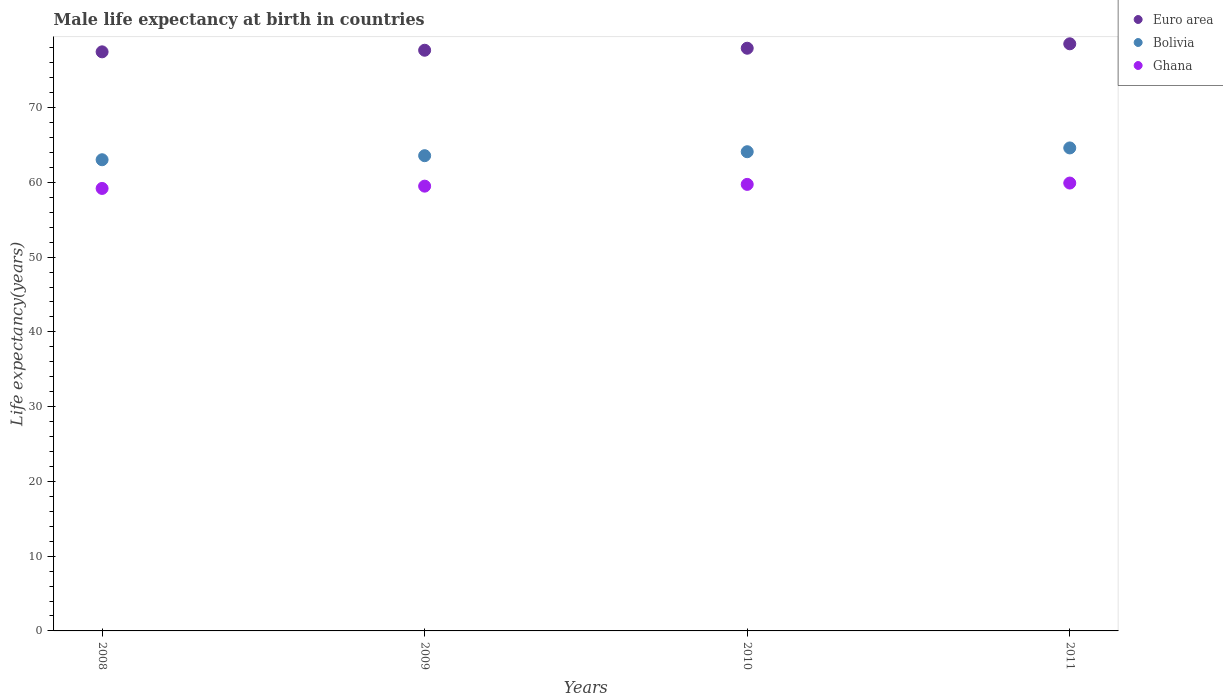How many different coloured dotlines are there?
Provide a succinct answer. 3. What is the male life expectancy at birth in Ghana in 2008?
Give a very brief answer. 59.19. Across all years, what is the maximum male life expectancy at birth in Bolivia?
Your answer should be very brief. 64.61. Across all years, what is the minimum male life expectancy at birth in Ghana?
Make the answer very short. 59.19. In which year was the male life expectancy at birth in Ghana maximum?
Offer a very short reply. 2011. In which year was the male life expectancy at birth in Bolivia minimum?
Your answer should be very brief. 2008. What is the total male life expectancy at birth in Euro area in the graph?
Offer a very short reply. 311.61. What is the difference between the male life expectancy at birth in Euro area in 2008 and that in 2010?
Provide a short and direct response. -0.48. What is the difference between the male life expectancy at birth in Bolivia in 2008 and the male life expectancy at birth in Euro area in 2010?
Give a very brief answer. -14.92. What is the average male life expectancy at birth in Ghana per year?
Offer a very short reply. 59.58. In the year 2010, what is the difference between the male life expectancy at birth in Euro area and male life expectancy at birth in Bolivia?
Give a very brief answer. 13.84. In how many years, is the male life expectancy at birth in Bolivia greater than 74 years?
Provide a short and direct response. 0. What is the ratio of the male life expectancy at birth in Euro area in 2008 to that in 2009?
Provide a short and direct response. 1. Is the male life expectancy at birth in Ghana in 2008 less than that in 2011?
Ensure brevity in your answer.  Yes. Is the difference between the male life expectancy at birth in Euro area in 2009 and 2010 greater than the difference between the male life expectancy at birth in Bolivia in 2009 and 2010?
Give a very brief answer. Yes. What is the difference between the highest and the second highest male life expectancy at birth in Bolivia?
Provide a short and direct response. 0.51. What is the difference between the highest and the lowest male life expectancy at birth in Bolivia?
Offer a very short reply. 1.58. Is it the case that in every year, the sum of the male life expectancy at birth in Euro area and male life expectancy at birth in Bolivia  is greater than the male life expectancy at birth in Ghana?
Keep it short and to the point. Yes. Is the male life expectancy at birth in Euro area strictly greater than the male life expectancy at birth in Bolivia over the years?
Keep it short and to the point. Yes. How many dotlines are there?
Offer a very short reply. 3. Does the graph contain any zero values?
Offer a very short reply. No. How are the legend labels stacked?
Provide a succinct answer. Vertical. What is the title of the graph?
Your answer should be compact. Male life expectancy at birth in countries. Does "Cayman Islands" appear as one of the legend labels in the graph?
Provide a short and direct response. No. What is the label or title of the Y-axis?
Provide a short and direct response. Life expectancy(years). What is the Life expectancy(years) in Euro area in 2008?
Your answer should be compact. 77.46. What is the Life expectancy(years) of Bolivia in 2008?
Offer a terse response. 63.03. What is the Life expectancy(years) in Ghana in 2008?
Your answer should be very brief. 59.19. What is the Life expectancy(years) in Euro area in 2009?
Provide a short and direct response. 77.67. What is the Life expectancy(years) in Bolivia in 2009?
Your answer should be compact. 63.57. What is the Life expectancy(years) in Ghana in 2009?
Offer a very short reply. 59.49. What is the Life expectancy(years) in Euro area in 2010?
Your response must be concise. 77.94. What is the Life expectancy(years) in Bolivia in 2010?
Make the answer very short. 64.1. What is the Life expectancy(years) in Ghana in 2010?
Provide a succinct answer. 59.73. What is the Life expectancy(years) of Euro area in 2011?
Provide a succinct answer. 78.53. What is the Life expectancy(years) in Bolivia in 2011?
Ensure brevity in your answer.  64.61. What is the Life expectancy(years) of Ghana in 2011?
Ensure brevity in your answer.  59.91. Across all years, what is the maximum Life expectancy(years) in Euro area?
Offer a terse response. 78.53. Across all years, what is the maximum Life expectancy(years) in Bolivia?
Make the answer very short. 64.61. Across all years, what is the maximum Life expectancy(years) in Ghana?
Provide a short and direct response. 59.91. Across all years, what is the minimum Life expectancy(years) in Euro area?
Your answer should be compact. 77.46. Across all years, what is the minimum Life expectancy(years) in Bolivia?
Provide a short and direct response. 63.03. Across all years, what is the minimum Life expectancy(years) in Ghana?
Offer a terse response. 59.19. What is the total Life expectancy(years) in Euro area in the graph?
Offer a terse response. 311.61. What is the total Life expectancy(years) in Bolivia in the graph?
Ensure brevity in your answer.  255.3. What is the total Life expectancy(years) of Ghana in the graph?
Make the answer very short. 238.32. What is the difference between the Life expectancy(years) of Euro area in 2008 and that in 2009?
Give a very brief answer. -0.21. What is the difference between the Life expectancy(years) in Bolivia in 2008 and that in 2009?
Keep it short and to the point. -0.54. What is the difference between the Life expectancy(years) of Ghana in 2008 and that in 2009?
Provide a succinct answer. -0.31. What is the difference between the Life expectancy(years) in Euro area in 2008 and that in 2010?
Provide a short and direct response. -0.48. What is the difference between the Life expectancy(years) of Bolivia in 2008 and that in 2010?
Keep it short and to the point. -1.07. What is the difference between the Life expectancy(years) in Ghana in 2008 and that in 2010?
Make the answer very short. -0.54. What is the difference between the Life expectancy(years) of Euro area in 2008 and that in 2011?
Your response must be concise. -1.07. What is the difference between the Life expectancy(years) in Bolivia in 2008 and that in 2011?
Ensure brevity in your answer.  -1.58. What is the difference between the Life expectancy(years) of Ghana in 2008 and that in 2011?
Give a very brief answer. -0.72. What is the difference between the Life expectancy(years) of Euro area in 2009 and that in 2010?
Offer a terse response. -0.27. What is the difference between the Life expectancy(years) in Bolivia in 2009 and that in 2010?
Your answer should be compact. -0.53. What is the difference between the Life expectancy(years) in Ghana in 2009 and that in 2010?
Offer a very short reply. -0.23. What is the difference between the Life expectancy(years) of Euro area in 2009 and that in 2011?
Provide a short and direct response. -0.86. What is the difference between the Life expectancy(years) in Bolivia in 2009 and that in 2011?
Offer a terse response. -1.04. What is the difference between the Life expectancy(years) in Ghana in 2009 and that in 2011?
Provide a succinct answer. -0.41. What is the difference between the Life expectancy(years) in Euro area in 2010 and that in 2011?
Keep it short and to the point. -0.59. What is the difference between the Life expectancy(years) of Bolivia in 2010 and that in 2011?
Keep it short and to the point. -0.51. What is the difference between the Life expectancy(years) in Ghana in 2010 and that in 2011?
Your response must be concise. -0.18. What is the difference between the Life expectancy(years) in Euro area in 2008 and the Life expectancy(years) in Bolivia in 2009?
Ensure brevity in your answer.  13.89. What is the difference between the Life expectancy(years) in Euro area in 2008 and the Life expectancy(years) in Ghana in 2009?
Ensure brevity in your answer.  17.96. What is the difference between the Life expectancy(years) of Bolivia in 2008 and the Life expectancy(years) of Ghana in 2009?
Your response must be concise. 3.53. What is the difference between the Life expectancy(years) in Euro area in 2008 and the Life expectancy(years) in Bolivia in 2010?
Provide a succinct answer. 13.36. What is the difference between the Life expectancy(years) of Euro area in 2008 and the Life expectancy(years) of Ghana in 2010?
Your response must be concise. 17.73. What is the difference between the Life expectancy(years) in Bolivia in 2008 and the Life expectancy(years) in Ghana in 2010?
Your answer should be very brief. 3.3. What is the difference between the Life expectancy(years) in Euro area in 2008 and the Life expectancy(years) in Bolivia in 2011?
Your answer should be compact. 12.85. What is the difference between the Life expectancy(years) in Euro area in 2008 and the Life expectancy(years) in Ghana in 2011?
Offer a terse response. 17.55. What is the difference between the Life expectancy(years) in Bolivia in 2008 and the Life expectancy(years) in Ghana in 2011?
Provide a succinct answer. 3.12. What is the difference between the Life expectancy(years) of Euro area in 2009 and the Life expectancy(years) of Bolivia in 2010?
Provide a succinct answer. 13.58. What is the difference between the Life expectancy(years) in Euro area in 2009 and the Life expectancy(years) in Ghana in 2010?
Offer a terse response. 17.94. What is the difference between the Life expectancy(years) of Bolivia in 2009 and the Life expectancy(years) of Ghana in 2010?
Your response must be concise. 3.84. What is the difference between the Life expectancy(years) in Euro area in 2009 and the Life expectancy(years) in Bolivia in 2011?
Keep it short and to the point. 13.07. What is the difference between the Life expectancy(years) in Euro area in 2009 and the Life expectancy(years) in Ghana in 2011?
Make the answer very short. 17.77. What is the difference between the Life expectancy(years) in Bolivia in 2009 and the Life expectancy(years) in Ghana in 2011?
Offer a very short reply. 3.66. What is the difference between the Life expectancy(years) of Euro area in 2010 and the Life expectancy(years) of Bolivia in 2011?
Ensure brevity in your answer.  13.34. What is the difference between the Life expectancy(years) of Euro area in 2010 and the Life expectancy(years) of Ghana in 2011?
Your answer should be very brief. 18.03. What is the difference between the Life expectancy(years) of Bolivia in 2010 and the Life expectancy(years) of Ghana in 2011?
Give a very brief answer. 4.19. What is the average Life expectancy(years) of Euro area per year?
Keep it short and to the point. 77.9. What is the average Life expectancy(years) of Bolivia per year?
Make the answer very short. 63.82. What is the average Life expectancy(years) in Ghana per year?
Your answer should be compact. 59.58. In the year 2008, what is the difference between the Life expectancy(years) of Euro area and Life expectancy(years) of Bolivia?
Make the answer very short. 14.43. In the year 2008, what is the difference between the Life expectancy(years) of Euro area and Life expectancy(years) of Ghana?
Offer a very short reply. 18.27. In the year 2008, what is the difference between the Life expectancy(years) in Bolivia and Life expectancy(years) in Ghana?
Keep it short and to the point. 3.84. In the year 2009, what is the difference between the Life expectancy(years) of Euro area and Life expectancy(years) of Bolivia?
Keep it short and to the point. 14.11. In the year 2009, what is the difference between the Life expectancy(years) of Euro area and Life expectancy(years) of Ghana?
Your answer should be very brief. 18.18. In the year 2009, what is the difference between the Life expectancy(years) in Bolivia and Life expectancy(years) in Ghana?
Your response must be concise. 4.07. In the year 2010, what is the difference between the Life expectancy(years) in Euro area and Life expectancy(years) in Bolivia?
Your answer should be compact. 13.84. In the year 2010, what is the difference between the Life expectancy(years) in Euro area and Life expectancy(years) in Ghana?
Your response must be concise. 18.21. In the year 2010, what is the difference between the Life expectancy(years) in Bolivia and Life expectancy(years) in Ghana?
Your answer should be very brief. 4.37. In the year 2011, what is the difference between the Life expectancy(years) in Euro area and Life expectancy(years) in Bolivia?
Make the answer very short. 13.93. In the year 2011, what is the difference between the Life expectancy(years) of Euro area and Life expectancy(years) of Ghana?
Make the answer very short. 18.63. In the year 2011, what is the difference between the Life expectancy(years) of Bolivia and Life expectancy(years) of Ghana?
Give a very brief answer. 4.7. What is the ratio of the Life expectancy(years) in Euro area in 2008 to that in 2009?
Make the answer very short. 1. What is the ratio of the Life expectancy(years) in Ghana in 2008 to that in 2009?
Give a very brief answer. 0.99. What is the ratio of the Life expectancy(years) of Euro area in 2008 to that in 2010?
Your response must be concise. 0.99. What is the ratio of the Life expectancy(years) of Bolivia in 2008 to that in 2010?
Your answer should be very brief. 0.98. What is the ratio of the Life expectancy(years) of Ghana in 2008 to that in 2010?
Offer a very short reply. 0.99. What is the ratio of the Life expectancy(years) of Euro area in 2008 to that in 2011?
Keep it short and to the point. 0.99. What is the ratio of the Life expectancy(years) of Bolivia in 2008 to that in 2011?
Offer a terse response. 0.98. What is the ratio of the Life expectancy(years) in Ghana in 2008 to that in 2011?
Your answer should be very brief. 0.99. What is the ratio of the Life expectancy(years) of Euro area in 2009 to that in 2010?
Provide a short and direct response. 1. What is the ratio of the Life expectancy(years) of Bolivia in 2009 to that in 2010?
Your response must be concise. 0.99. What is the ratio of the Life expectancy(years) of Bolivia in 2009 to that in 2011?
Your answer should be compact. 0.98. What is the ratio of the Life expectancy(years) in Ghana in 2010 to that in 2011?
Give a very brief answer. 1. What is the difference between the highest and the second highest Life expectancy(years) of Euro area?
Your answer should be very brief. 0.59. What is the difference between the highest and the second highest Life expectancy(years) in Bolivia?
Ensure brevity in your answer.  0.51. What is the difference between the highest and the second highest Life expectancy(years) in Ghana?
Offer a very short reply. 0.18. What is the difference between the highest and the lowest Life expectancy(years) in Euro area?
Ensure brevity in your answer.  1.07. What is the difference between the highest and the lowest Life expectancy(years) in Bolivia?
Your answer should be very brief. 1.58. What is the difference between the highest and the lowest Life expectancy(years) in Ghana?
Provide a succinct answer. 0.72. 